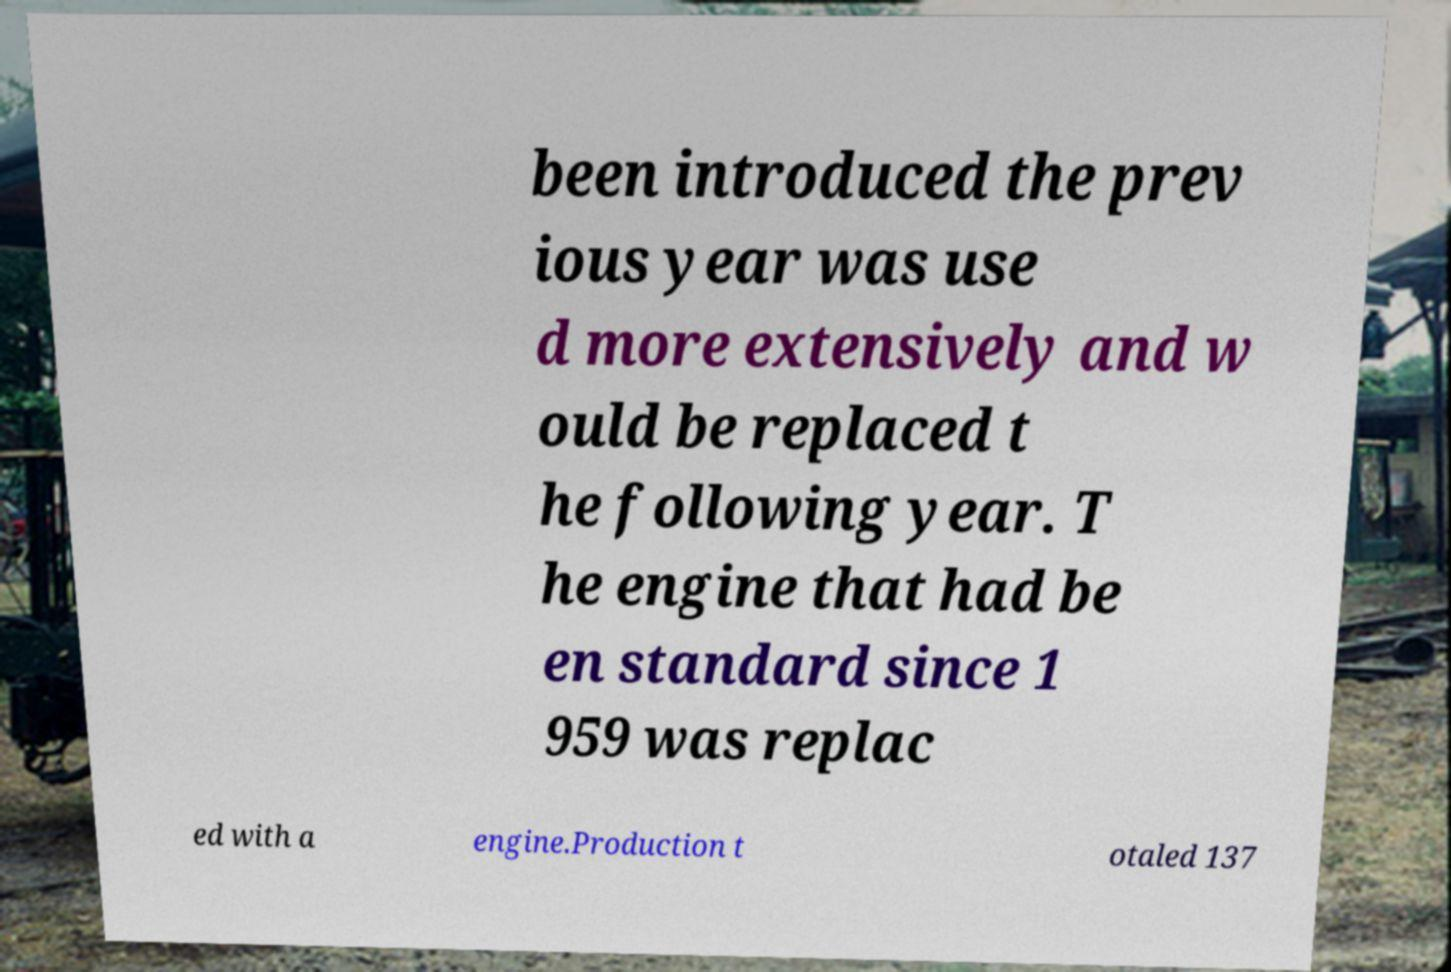There's text embedded in this image that I need extracted. Can you transcribe it verbatim? been introduced the prev ious year was use d more extensively and w ould be replaced t he following year. T he engine that had be en standard since 1 959 was replac ed with a engine.Production t otaled 137 